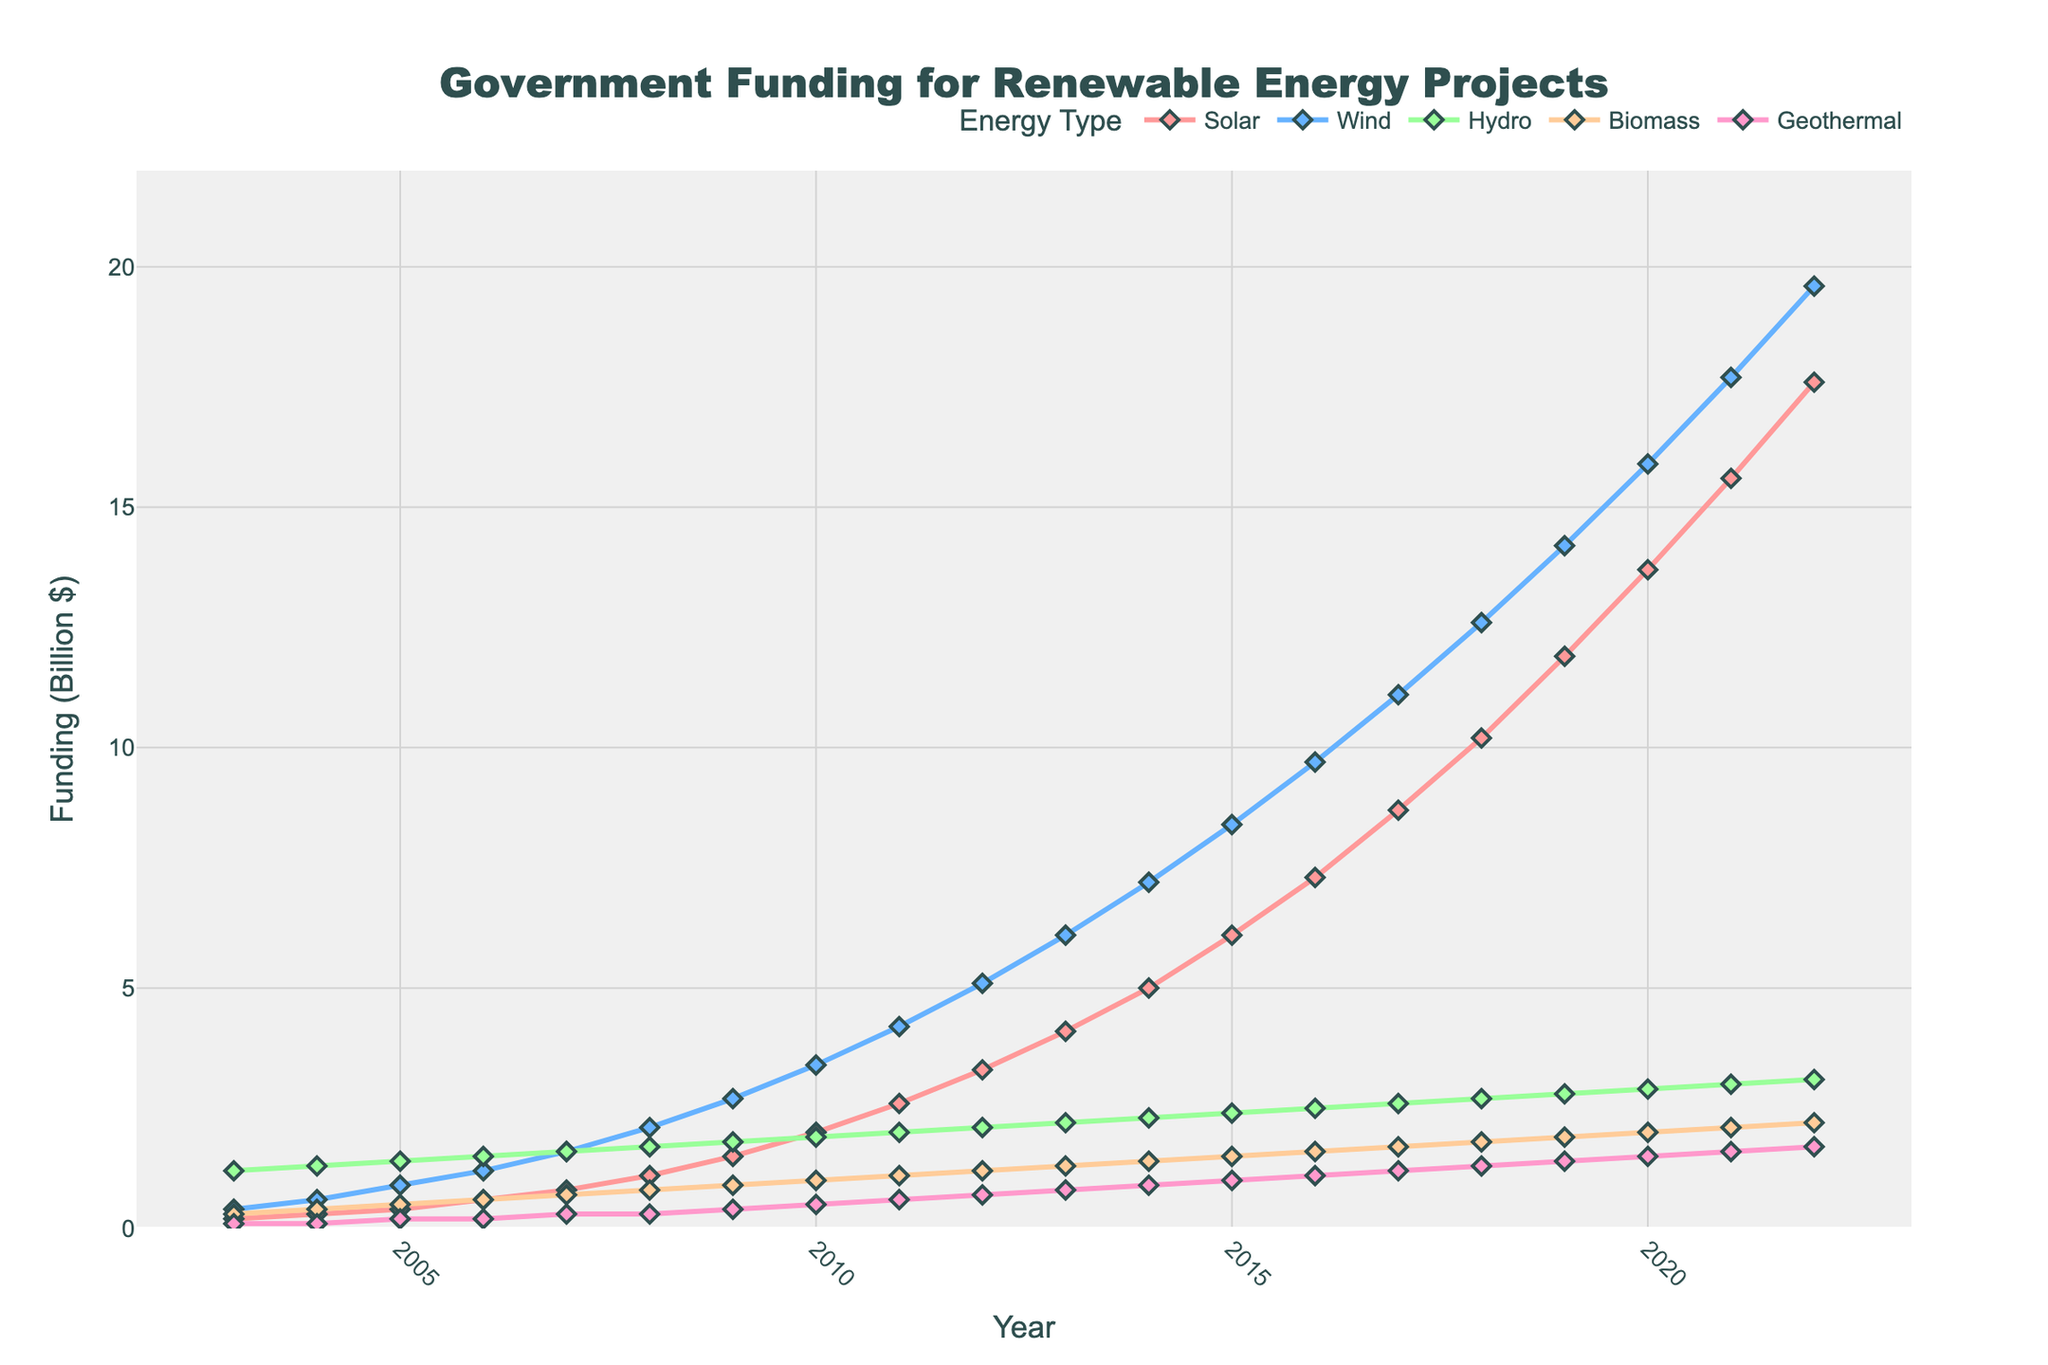what year did solar funding surpass 5 billion dollars? Look at the line representing solar funding and find the year when it first crosses the 5 billion-dollar mark. This happens around the 2014 mark.
Answer: 2014 By how much did wind funding increase from 2003 to 2022? Subtract the wind funding value in 2003 (0.4 billion dollars) from the value in 2022 (19.6 billion dollars). The difference is 19.6 - 0.4.
Answer: 19.2 billion dollars Which energy type experienced the highest growth in funding over the 20 years? Compare the beginning and end values for each energy type over the time period. Solar funding starts at 0.2 billion dollars in 2003 and ends at 17.6 billion dollars in 2022, which is the highest increase.
Answer: Solar How does the funding for geothermal in 2022 compare to biomass in 2010? Identify the geothermal funding for 2022 (1.7 billion dollars) and biomass funding for 2010 (1.0 billion dollars) and then compare the two values.
Answer: Geothermal in 2022 is higher What is the trend in hydro funding from 2003 to 2022? Observe the hydro funding line and note that it shows a relatively stable trend with slight increases over the 20 years.
Answer: Slight increase How much more was solar funding compared to geothermal funding in 2022? Find the values for solar (17.6 billion dollars) and geothermal (1.7 billion dollars) in 2022 and then subtract the two values, 17.6 - 1.7.
Answer: 15.9 billion dollars Which year saw the largest one-year increase in wind funding? Examine the increments year by year for wind funding and identify the largest jump, which is between 2014 and 2015 (7.2 to 8.4 billion dollars).
Answer: 2014-2015 By what factor did biomass funding increase from 2003 to 2022? Divide the biomass funding value in 2022 (2.2 billion dollars) by that in 2003 (0.3 billion dollars).
Answer: About 7.3 Is there any year where hydro funding was higher than wind funding? Compare the lines for hydro and wind year by year and notice that such a condition never occurs; wind funding is always higher after 2003.
Answer: No What's the total funding for all renewable energy types in 2016? Add the funding values for all energy types in 2016: Solar (7.3) + Wind (9.7) + Hydro (2.5) + Biomass (1.6) + Geothermal (1.1).
Answer: 22.2 billion dollars 